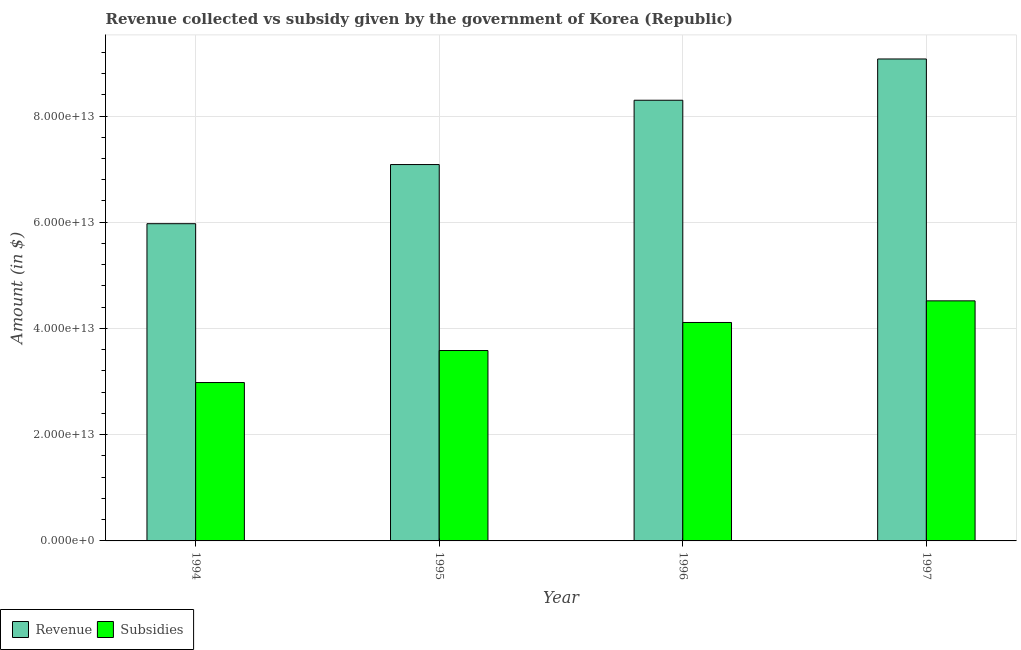How many different coloured bars are there?
Provide a succinct answer. 2. How many groups of bars are there?
Provide a short and direct response. 4. How many bars are there on the 4th tick from the right?
Offer a very short reply. 2. What is the amount of subsidies given in 1994?
Ensure brevity in your answer.  2.98e+13. Across all years, what is the maximum amount of subsidies given?
Provide a short and direct response. 4.52e+13. Across all years, what is the minimum amount of revenue collected?
Keep it short and to the point. 5.97e+13. In which year was the amount of revenue collected maximum?
Make the answer very short. 1997. What is the total amount of subsidies given in the graph?
Your answer should be very brief. 1.52e+14. What is the difference between the amount of revenue collected in 1994 and that in 1995?
Your answer should be compact. -1.11e+13. What is the difference between the amount of subsidies given in 1994 and the amount of revenue collected in 1996?
Make the answer very short. -1.13e+13. What is the average amount of subsidies given per year?
Make the answer very short. 3.80e+13. In the year 1996, what is the difference between the amount of subsidies given and amount of revenue collected?
Provide a succinct answer. 0. In how many years, is the amount of revenue collected greater than 8000000000000 $?
Offer a terse response. 4. What is the ratio of the amount of subsidies given in 1994 to that in 1997?
Make the answer very short. 0.66. Is the amount of revenue collected in 1995 less than that in 1996?
Give a very brief answer. Yes. Is the difference between the amount of revenue collected in 1996 and 1997 greater than the difference between the amount of subsidies given in 1996 and 1997?
Your answer should be compact. No. What is the difference between the highest and the second highest amount of revenue collected?
Give a very brief answer. 7.77e+12. What is the difference between the highest and the lowest amount of revenue collected?
Your answer should be very brief. 3.10e+13. What does the 1st bar from the left in 1995 represents?
Your response must be concise. Revenue. What does the 1st bar from the right in 1994 represents?
Provide a short and direct response. Subsidies. Are all the bars in the graph horizontal?
Keep it short and to the point. No. What is the difference between two consecutive major ticks on the Y-axis?
Offer a very short reply. 2.00e+13. Does the graph contain any zero values?
Offer a terse response. No. Where does the legend appear in the graph?
Ensure brevity in your answer.  Bottom left. How many legend labels are there?
Offer a terse response. 2. What is the title of the graph?
Offer a very short reply. Revenue collected vs subsidy given by the government of Korea (Republic). What is the label or title of the X-axis?
Your answer should be compact. Year. What is the label or title of the Y-axis?
Give a very brief answer. Amount (in $). What is the Amount (in $) in Revenue in 1994?
Your response must be concise. 5.97e+13. What is the Amount (in $) of Subsidies in 1994?
Provide a short and direct response. 2.98e+13. What is the Amount (in $) in Revenue in 1995?
Make the answer very short. 7.09e+13. What is the Amount (in $) of Subsidies in 1995?
Offer a very short reply. 3.58e+13. What is the Amount (in $) in Revenue in 1996?
Offer a very short reply. 8.30e+13. What is the Amount (in $) of Subsidies in 1996?
Ensure brevity in your answer.  4.11e+13. What is the Amount (in $) in Revenue in 1997?
Ensure brevity in your answer.  9.07e+13. What is the Amount (in $) of Subsidies in 1997?
Your answer should be very brief. 4.52e+13. Across all years, what is the maximum Amount (in $) of Revenue?
Ensure brevity in your answer.  9.07e+13. Across all years, what is the maximum Amount (in $) of Subsidies?
Provide a succinct answer. 4.52e+13. Across all years, what is the minimum Amount (in $) of Revenue?
Your answer should be compact. 5.97e+13. Across all years, what is the minimum Amount (in $) in Subsidies?
Your response must be concise. 2.98e+13. What is the total Amount (in $) in Revenue in the graph?
Provide a short and direct response. 3.04e+14. What is the total Amount (in $) of Subsidies in the graph?
Your response must be concise. 1.52e+14. What is the difference between the Amount (in $) in Revenue in 1994 and that in 1995?
Provide a short and direct response. -1.11e+13. What is the difference between the Amount (in $) in Subsidies in 1994 and that in 1995?
Provide a short and direct response. -6.03e+12. What is the difference between the Amount (in $) in Revenue in 1994 and that in 1996?
Make the answer very short. -2.32e+13. What is the difference between the Amount (in $) in Subsidies in 1994 and that in 1996?
Your response must be concise. -1.13e+13. What is the difference between the Amount (in $) of Revenue in 1994 and that in 1997?
Provide a short and direct response. -3.10e+13. What is the difference between the Amount (in $) of Subsidies in 1994 and that in 1997?
Offer a terse response. -1.54e+13. What is the difference between the Amount (in $) of Revenue in 1995 and that in 1996?
Your answer should be very brief. -1.21e+13. What is the difference between the Amount (in $) in Subsidies in 1995 and that in 1996?
Your response must be concise. -5.28e+12. What is the difference between the Amount (in $) of Revenue in 1995 and that in 1997?
Offer a terse response. -1.99e+13. What is the difference between the Amount (in $) in Subsidies in 1995 and that in 1997?
Offer a terse response. -9.35e+12. What is the difference between the Amount (in $) of Revenue in 1996 and that in 1997?
Your answer should be compact. -7.77e+12. What is the difference between the Amount (in $) of Subsidies in 1996 and that in 1997?
Your answer should be compact. -4.07e+12. What is the difference between the Amount (in $) in Revenue in 1994 and the Amount (in $) in Subsidies in 1995?
Your response must be concise. 2.39e+13. What is the difference between the Amount (in $) of Revenue in 1994 and the Amount (in $) of Subsidies in 1996?
Your response must be concise. 1.86e+13. What is the difference between the Amount (in $) of Revenue in 1994 and the Amount (in $) of Subsidies in 1997?
Your response must be concise. 1.45e+13. What is the difference between the Amount (in $) of Revenue in 1995 and the Amount (in $) of Subsidies in 1996?
Provide a succinct answer. 2.97e+13. What is the difference between the Amount (in $) of Revenue in 1995 and the Amount (in $) of Subsidies in 1997?
Provide a short and direct response. 2.57e+13. What is the difference between the Amount (in $) in Revenue in 1996 and the Amount (in $) in Subsidies in 1997?
Ensure brevity in your answer.  3.78e+13. What is the average Amount (in $) of Revenue per year?
Ensure brevity in your answer.  7.61e+13. What is the average Amount (in $) of Subsidies per year?
Your answer should be very brief. 3.80e+13. In the year 1994, what is the difference between the Amount (in $) in Revenue and Amount (in $) in Subsidies?
Your answer should be compact. 2.99e+13. In the year 1995, what is the difference between the Amount (in $) in Revenue and Amount (in $) in Subsidies?
Your answer should be compact. 3.50e+13. In the year 1996, what is the difference between the Amount (in $) of Revenue and Amount (in $) of Subsidies?
Give a very brief answer. 4.18e+13. In the year 1997, what is the difference between the Amount (in $) in Revenue and Amount (in $) in Subsidies?
Ensure brevity in your answer.  4.55e+13. What is the ratio of the Amount (in $) in Revenue in 1994 to that in 1995?
Provide a short and direct response. 0.84. What is the ratio of the Amount (in $) of Subsidies in 1994 to that in 1995?
Provide a short and direct response. 0.83. What is the ratio of the Amount (in $) of Revenue in 1994 to that in 1996?
Ensure brevity in your answer.  0.72. What is the ratio of the Amount (in $) in Subsidies in 1994 to that in 1996?
Offer a terse response. 0.73. What is the ratio of the Amount (in $) of Revenue in 1994 to that in 1997?
Provide a succinct answer. 0.66. What is the ratio of the Amount (in $) of Subsidies in 1994 to that in 1997?
Give a very brief answer. 0.66. What is the ratio of the Amount (in $) in Revenue in 1995 to that in 1996?
Make the answer very short. 0.85. What is the ratio of the Amount (in $) of Subsidies in 1995 to that in 1996?
Keep it short and to the point. 0.87. What is the ratio of the Amount (in $) of Revenue in 1995 to that in 1997?
Your answer should be compact. 0.78. What is the ratio of the Amount (in $) of Subsidies in 1995 to that in 1997?
Provide a short and direct response. 0.79. What is the ratio of the Amount (in $) in Revenue in 1996 to that in 1997?
Your answer should be very brief. 0.91. What is the ratio of the Amount (in $) of Subsidies in 1996 to that in 1997?
Offer a terse response. 0.91. What is the difference between the highest and the second highest Amount (in $) of Revenue?
Offer a very short reply. 7.77e+12. What is the difference between the highest and the second highest Amount (in $) in Subsidies?
Make the answer very short. 4.07e+12. What is the difference between the highest and the lowest Amount (in $) of Revenue?
Make the answer very short. 3.10e+13. What is the difference between the highest and the lowest Amount (in $) of Subsidies?
Your answer should be very brief. 1.54e+13. 